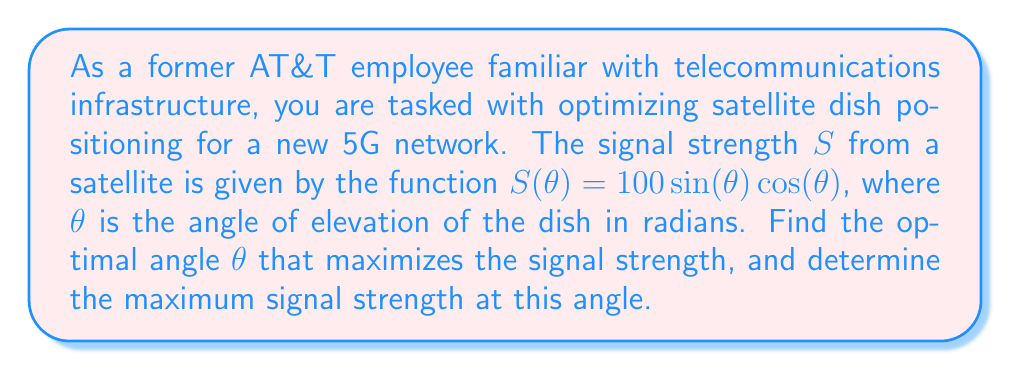Give your solution to this math problem. To solve this problem, we'll use calculus to find the maximum of the given function:

1) The signal strength function is $S(\theta) = 100\sin(\theta)\cos(\theta)$.

2) To find the maximum, we need to find where the derivative equals zero:

   $$\frac{dS}{d\theta} = 100[\cos^2(\theta) - \sin^2(\theta)]$$

3) Set this equal to zero:

   $$100[\cos^2(\theta) - \sin^2(\theta)] = 0$$

4) Simplify:

   $$\cos^2(\theta) - \sin^2(\theta) = 0$$

5) Recall the trigonometric identity $\cos(2\theta) = \cos^2(\theta) - \sin^2(\theta)$:

   $$\cos(2\theta) = 0$$

6) Solve for $\theta$:

   $$2\theta = \frac{\pi}{2} \text{ or } \frac{3\pi}{2}$$
   $$\theta = \frac{\pi}{4} \text{ or } \frac{3\pi}{4}$$

7) To determine which of these is the maximum (rather than minimum), we can check the second derivative or compare values:

   $$S(\frac{\pi}{4}) = 100\sin(\frac{\pi}{4})\cos(\frac{\pi}{4}) = 100 \cdot \frac{1}{\sqrt{2}} \cdot \frac{1}{\sqrt{2}} = 50$$
   $$S(\frac{3\pi}{4}) = 100\sin(\frac{3\pi}{4})\cos(\frac{3\pi}{4}) = 100 \cdot \frac{\sqrt{2}}{2} \cdot (-\frac{\sqrt{2}}{2}) = -50$$

Therefore, the maximum occurs at $\theta = \frac{\pi}{4}$ radians, or 45 degrees.

The maximum signal strength is 50 units.
Answer: The optimal angle for the satellite dish is $\frac{\pi}{4}$ radians or 45 degrees, and the maximum signal strength at this angle is 50 units. 